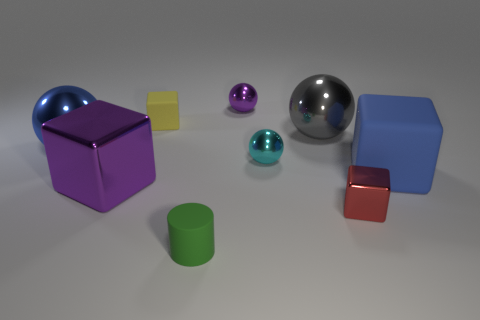Is the number of red metal blocks left of the tiny green matte cylinder the same as the number of large gray balls that are to the left of the purple shiny ball?
Offer a terse response. Yes. What number of other things are there of the same shape as the yellow thing?
Your answer should be compact. 3. Does the blue object left of the small red shiny block have the same size as the metal block that is to the right of the small yellow matte object?
Make the answer very short. No. How many cubes are either yellow rubber things or large metallic objects?
Your answer should be very brief. 2. How many metallic objects are blue spheres or tiny red blocks?
Keep it short and to the point. 2. What is the size of the blue object that is the same shape as the big gray shiny object?
Offer a very short reply. Large. Is there any other thing that has the same size as the red metal block?
Offer a very short reply. Yes. Is the size of the blue rubber cube the same as the yellow rubber object left of the small red block?
Keep it short and to the point. No. There is a large blue thing left of the blue rubber thing; what is its shape?
Your answer should be very brief. Sphere. There is a large shiny sphere on the right side of the purple shiny thing on the right side of the green thing; what is its color?
Keep it short and to the point. Gray. 